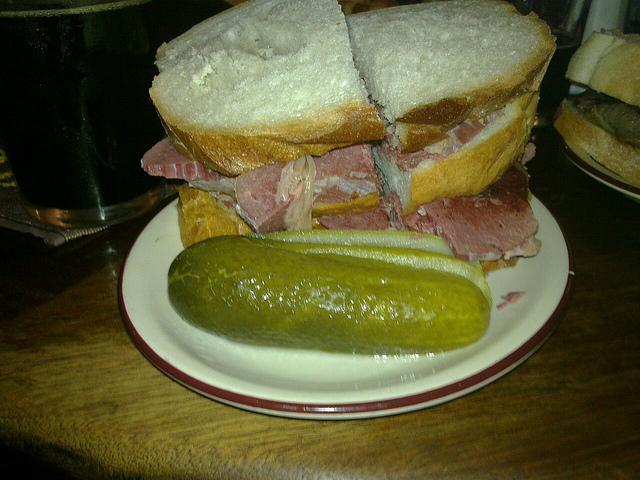How many sandwiches can you see?
Give a very brief answer. 2. How many cups are there?
Give a very brief answer. 1. How many women are in between the chains of the swing?
Give a very brief answer. 0. 